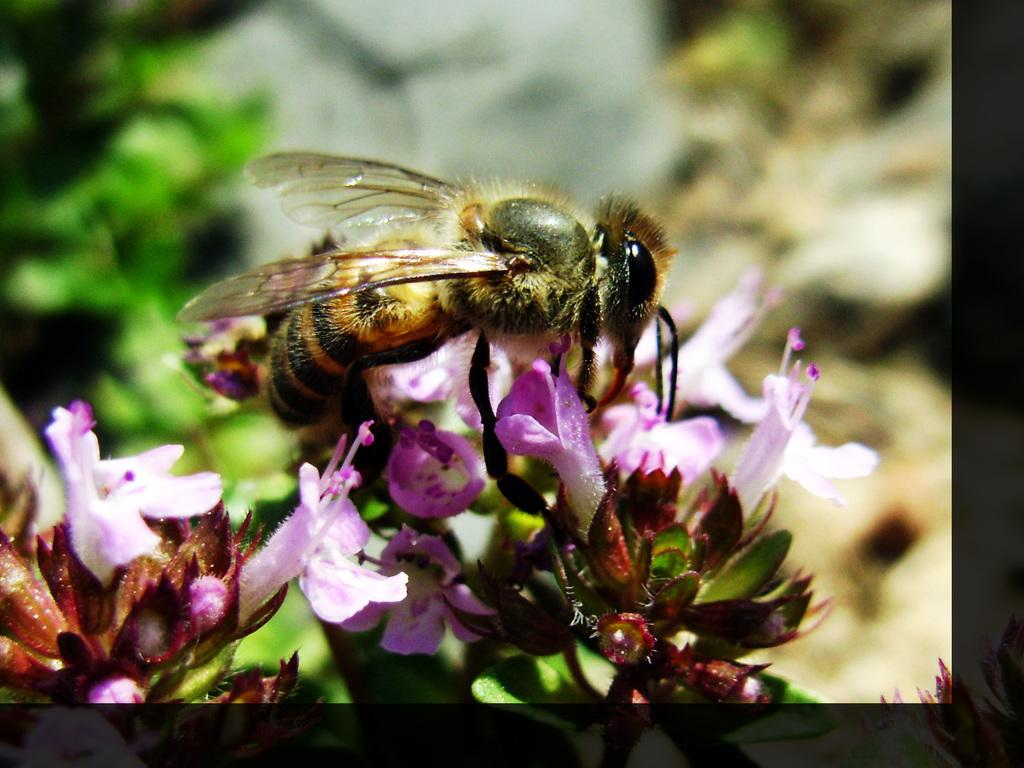What type of creature is present in the image? There is an insect in the image. What colors can be seen on the insect? The insect has black and brown color. Where is the insect located in the image? The insect is on the flowers. What colors are the flowers? The flowers are white and purple. How would you describe the background of the image? The background of the image is blurred. What type of cushion is the doctor sitting on in the image? There is no doctor or cushion present in the image; it features an insect on flowers with a blurred background. 